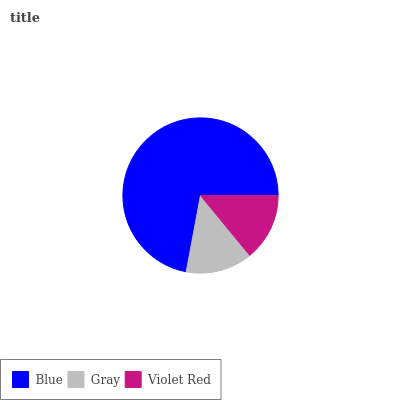Is Gray the minimum?
Answer yes or no. Yes. Is Blue the maximum?
Answer yes or no. Yes. Is Violet Red the minimum?
Answer yes or no. No. Is Violet Red the maximum?
Answer yes or no. No. Is Violet Red greater than Gray?
Answer yes or no. Yes. Is Gray less than Violet Red?
Answer yes or no. Yes. Is Gray greater than Violet Red?
Answer yes or no. No. Is Violet Red less than Gray?
Answer yes or no. No. Is Violet Red the high median?
Answer yes or no. Yes. Is Violet Red the low median?
Answer yes or no. Yes. Is Blue the high median?
Answer yes or no. No. Is Gray the low median?
Answer yes or no. No. 